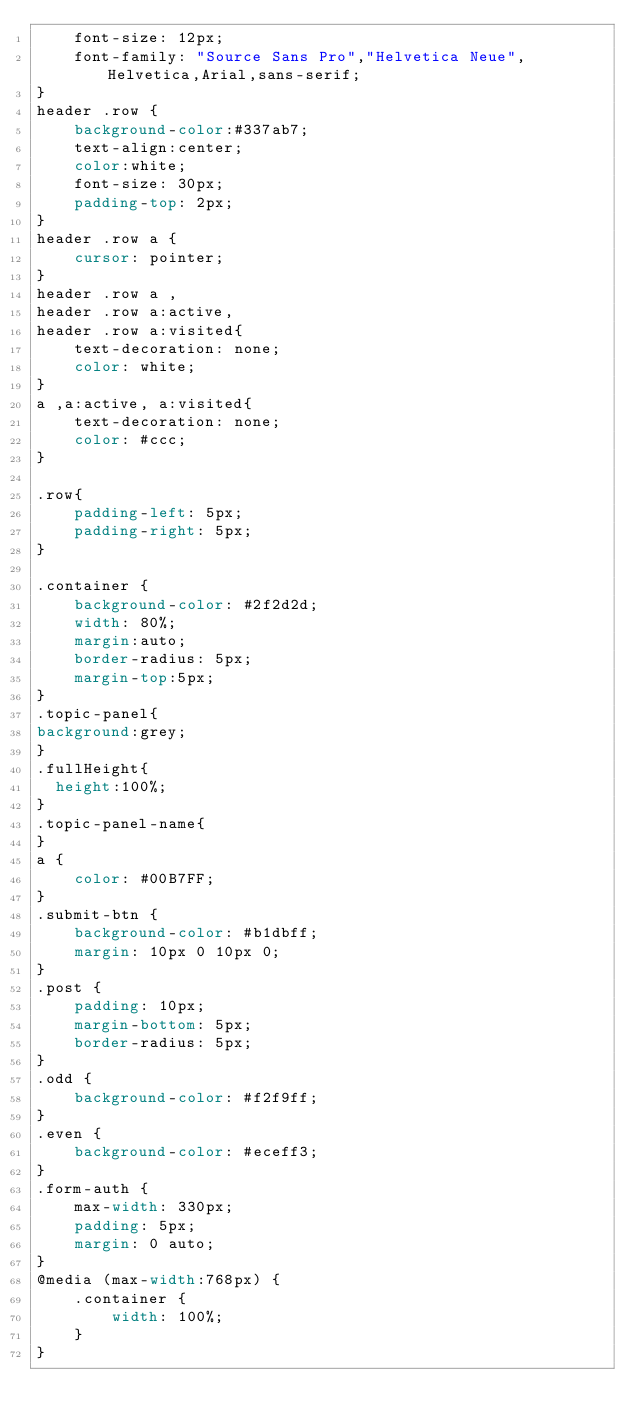<code> <loc_0><loc_0><loc_500><loc_500><_CSS_>	font-size: 12px;
	font-family: "Source Sans Pro","Helvetica Neue",Helvetica,Arial,sans-serif;
}
header .row {
	background-color:#337ab7;
	text-align:center;
	color:white;
	font-size: 30px;
	padding-top: 2px;
}
header .row a {
	cursor: pointer;
}
header .row a ,
header .row a:active,
header .row a:visited{
	text-decoration: none;
	color: white;
}
a ,a:active, a:visited{
	text-decoration: none;
	color: #ccc;
}

.row{
	padding-left: 5px;
	padding-right: 5px;
}

.container {
	background-color: #2f2d2d;
	width: 80%;
	margin:auto;
	border-radius: 5px;
	margin-top:5px;
}
.topic-panel{
background:grey;
}
.fullHeight{
  height:100%;
}
.topic-panel-name{
}
a {
	color: #00B7FF;
}
.submit-btn {
	background-color: #b1dbff;
	margin: 10px 0 10px 0;
}
.post {
	padding: 10px;
	margin-bottom: 5px;
	border-radius: 5px;
}
.odd {
	background-color: #f2f9ff;
}
.even {
	background-color: #eceff3;
}
.form-auth {
	max-width: 330px;
	padding: 5px;
	margin: 0 auto;
}
@media (max-width:768px) {
	.container {
		width: 100%;
	}
}
</code> 